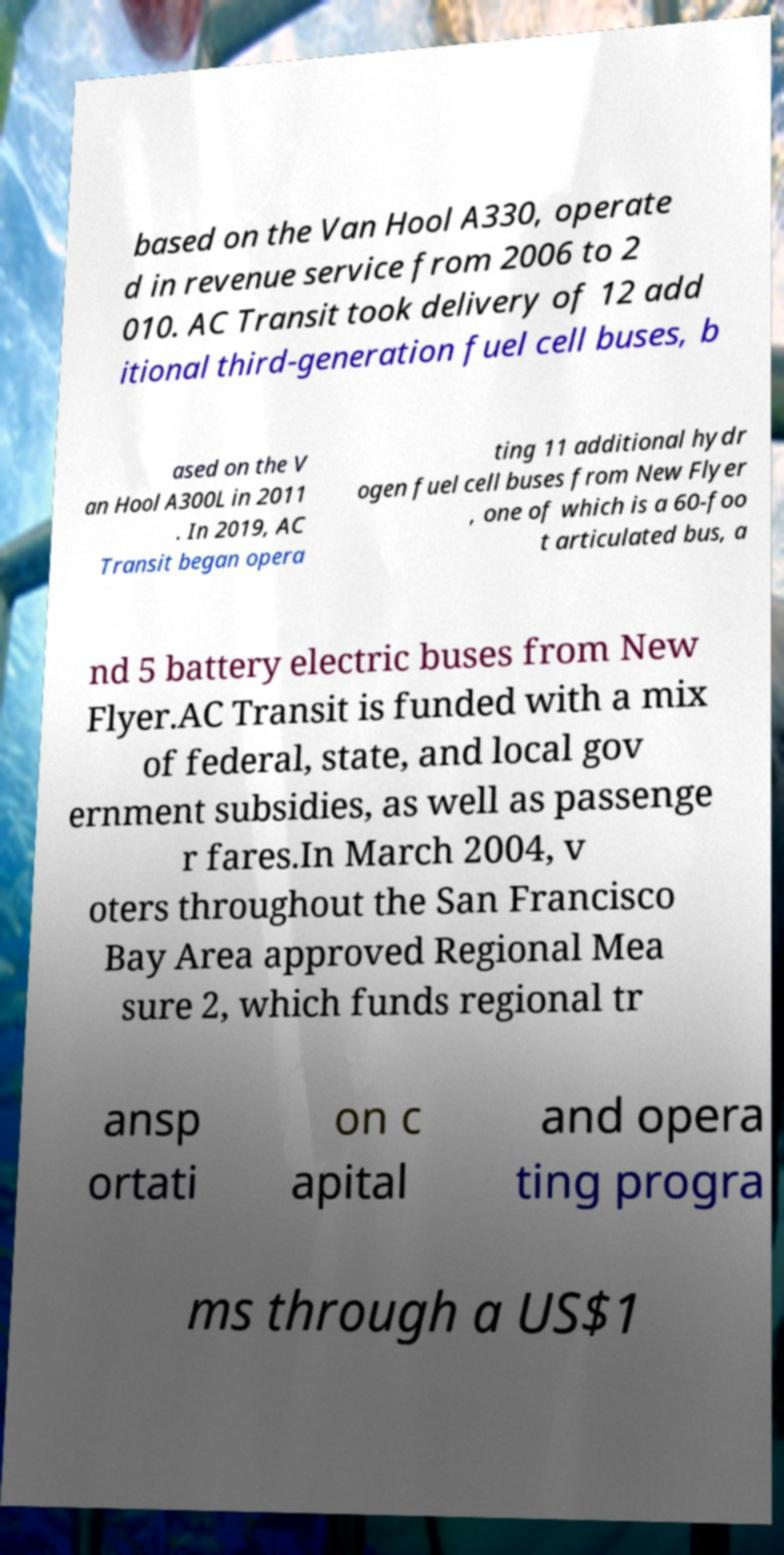Can you accurately transcribe the text from the provided image for me? based on the Van Hool A330, operate d in revenue service from 2006 to 2 010. AC Transit took delivery of 12 add itional third-generation fuel cell buses, b ased on the V an Hool A300L in 2011 . In 2019, AC Transit began opera ting 11 additional hydr ogen fuel cell buses from New Flyer , one of which is a 60-foo t articulated bus, a nd 5 battery electric buses from New Flyer.AC Transit is funded with a mix of federal, state, and local gov ernment subsidies, as well as passenge r fares.In March 2004, v oters throughout the San Francisco Bay Area approved Regional Mea sure 2, which funds regional tr ansp ortati on c apital and opera ting progra ms through a US$1 